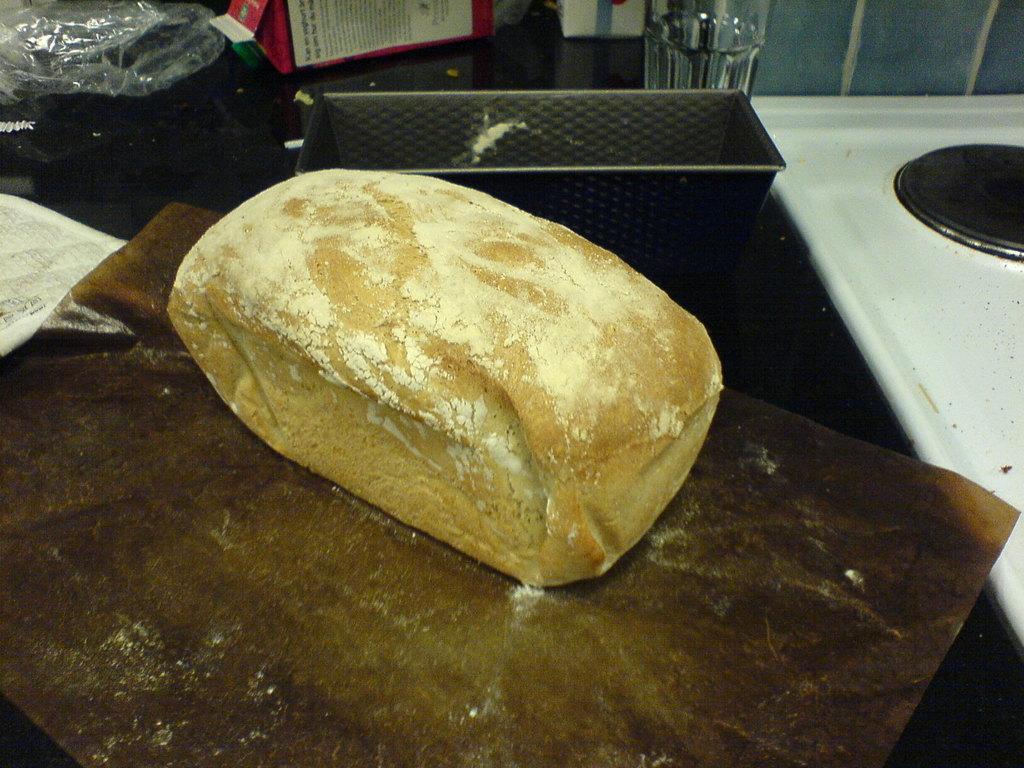Can you describe this image briefly? In this image, we can see a bread brick with powder is placed on the brown paper. Here we can see few objects, glass, white stove, container, cover. 